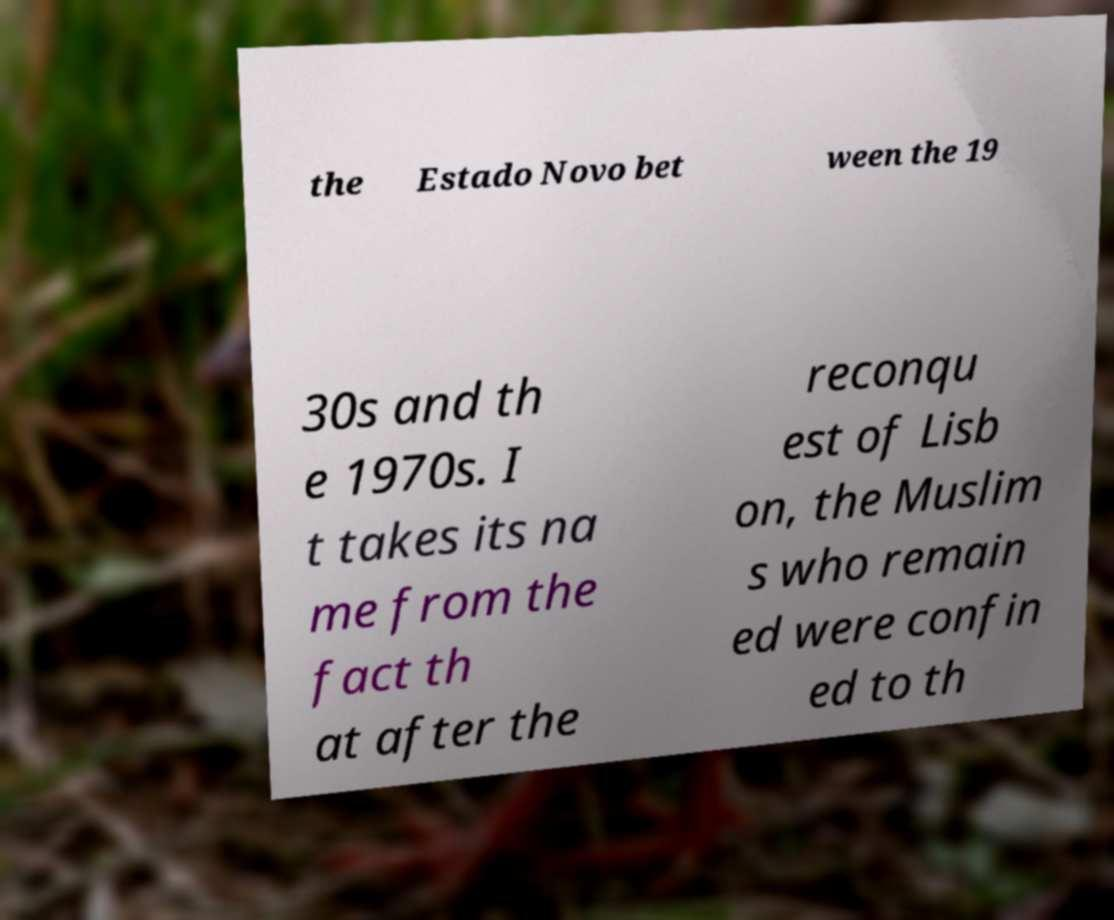Please identify and transcribe the text found in this image. the Estado Novo bet ween the 19 30s and th e 1970s. I t takes its na me from the fact th at after the reconqu est of Lisb on, the Muslim s who remain ed were confin ed to th 